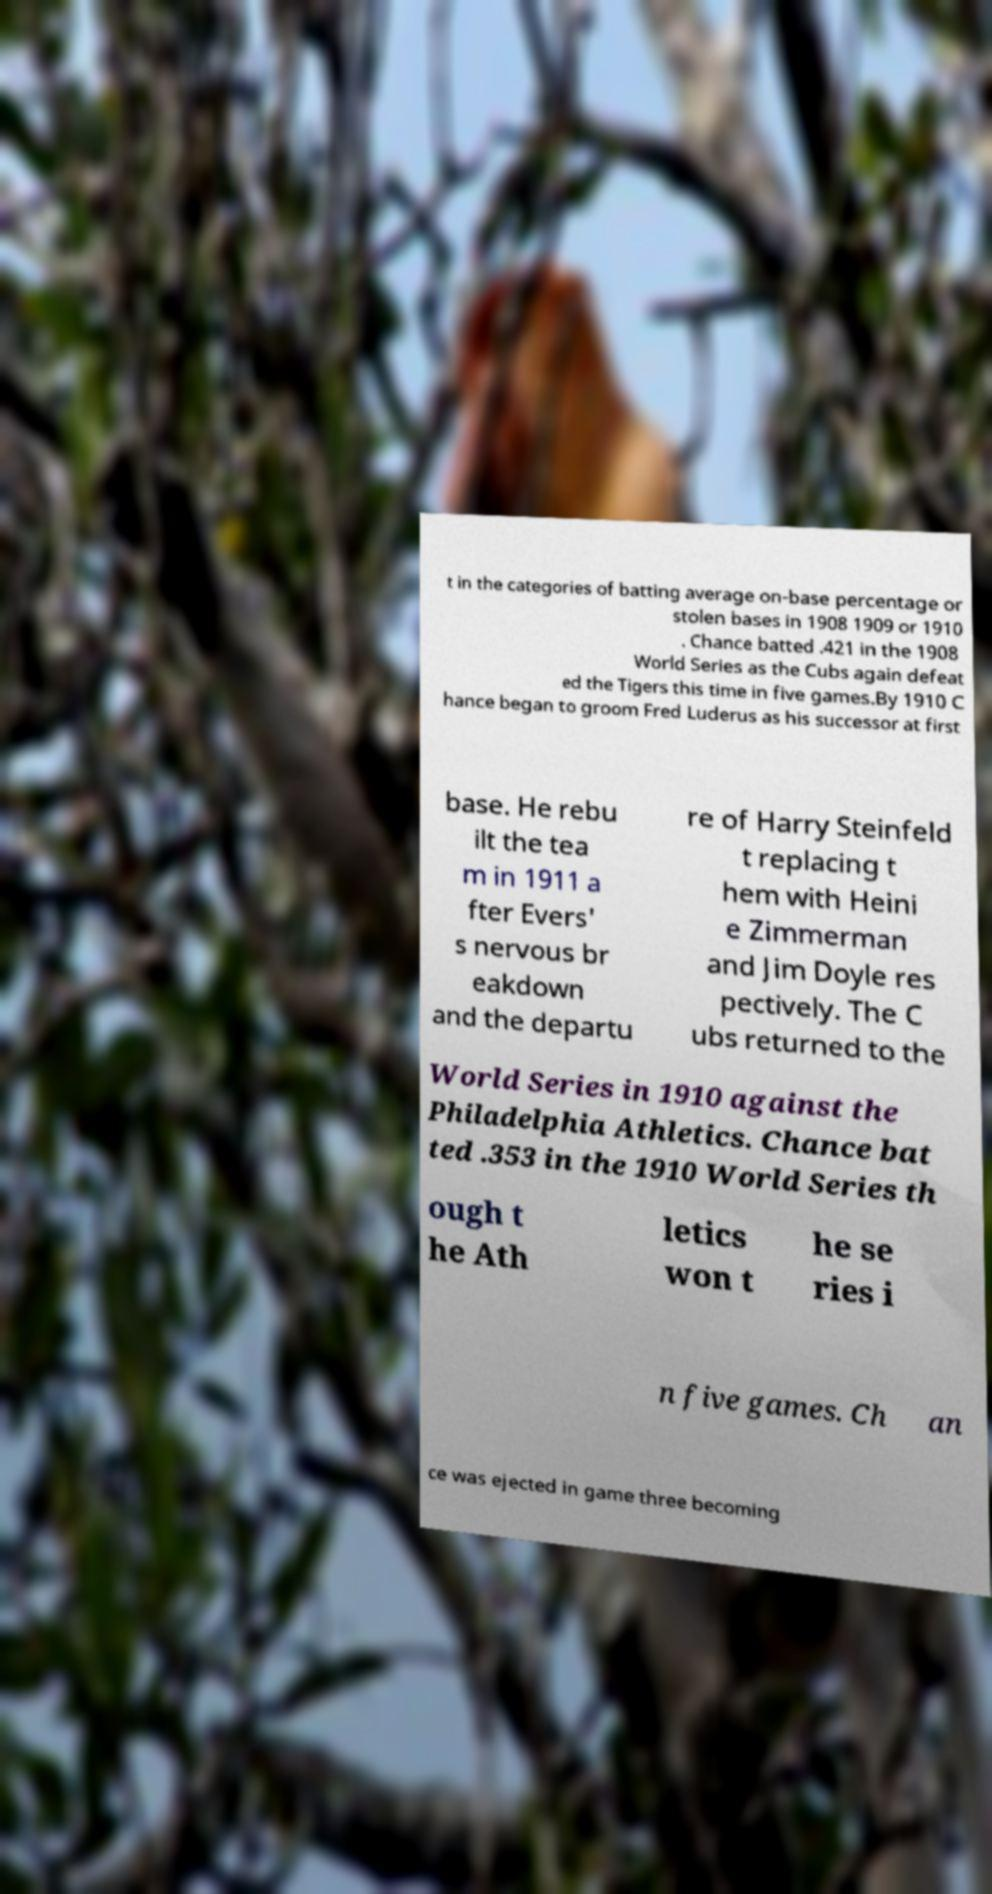Could you assist in decoding the text presented in this image and type it out clearly? t in the categories of batting average on-base percentage or stolen bases in 1908 1909 or 1910 . Chance batted .421 in the 1908 World Series as the Cubs again defeat ed the Tigers this time in five games.By 1910 C hance began to groom Fred Luderus as his successor at first base. He rebu ilt the tea m in 1911 a fter Evers' s nervous br eakdown and the departu re of Harry Steinfeld t replacing t hem with Heini e Zimmerman and Jim Doyle res pectively. The C ubs returned to the World Series in 1910 against the Philadelphia Athletics. Chance bat ted .353 in the 1910 World Series th ough t he Ath letics won t he se ries i n five games. Ch an ce was ejected in game three becoming 